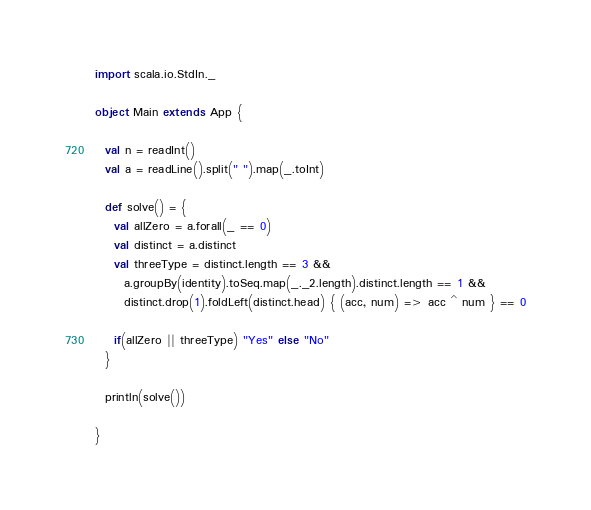<code> <loc_0><loc_0><loc_500><loc_500><_Scala_>import scala.io.StdIn._

object Main extends App {

  val n = readInt()
  val a = readLine().split(" ").map(_.toInt)

  def solve() = {
    val allZero = a.forall(_ == 0)
    val distinct = a.distinct
    val threeType = distinct.length == 3 &&
      a.groupBy(identity).toSeq.map(_._2.length).distinct.length == 1 &&
      distinct.drop(1).foldLeft(distinct.head) { (acc, num) => acc ^ num } == 0
    
    if(allZero || threeType) "Yes" else "No"
  }

  println(solve())

}

</code> 